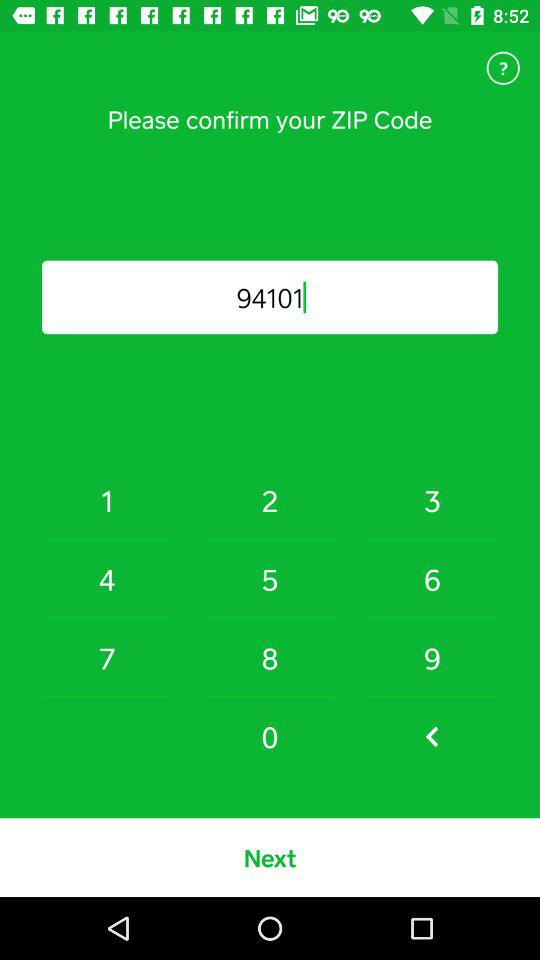What is the ZIP Code? The ZIP Code is 94101. 